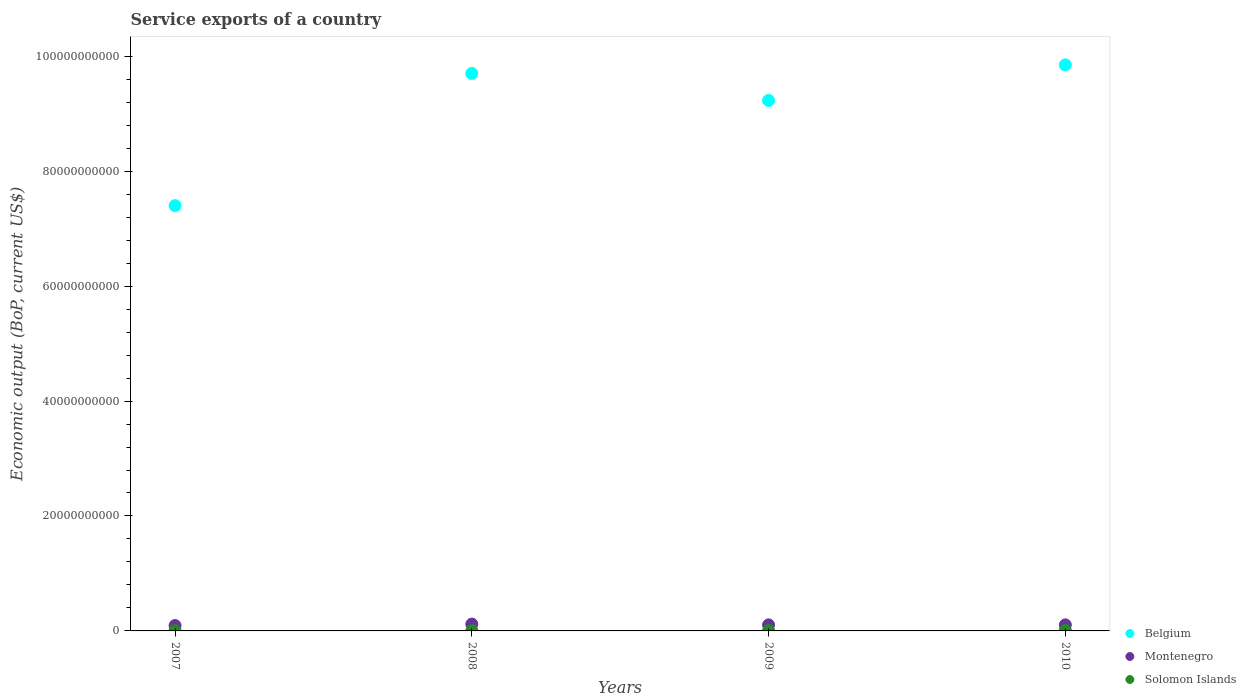What is the service exports in Montenegro in 2007?
Give a very brief answer. 9.33e+08. Across all years, what is the maximum service exports in Belgium?
Give a very brief answer. 9.85e+1. Across all years, what is the minimum service exports in Belgium?
Keep it short and to the point. 7.40e+1. In which year was the service exports in Montenegro minimum?
Offer a very short reply. 2007. What is the total service exports in Belgium in the graph?
Your response must be concise. 3.62e+11. What is the difference between the service exports in Solomon Islands in 2007 and that in 2008?
Your response must be concise. 4.59e+06. What is the difference between the service exports in Solomon Islands in 2008 and the service exports in Belgium in 2007?
Your answer should be compact. -7.40e+1. What is the average service exports in Belgium per year?
Keep it short and to the point. 9.05e+1. In the year 2009, what is the difference between the service exports in Belgium and service exports in Solomon Islands?
Offer a terse response. 9.22e+1. What is the ratio of the service exports in Montenegro in 2007 to that in 2010?
Your answer should be compact. 0.89. What is the difference between the highest and the second highest service exports in Montenegro?
Provide a short and direct response. 1.39e+08. What is the difference between the highest and the lowest service exports in Solomon Islands?
Provide a succinct answer. 4.23e+07. In how many years, is the service exports in Belgium greater than the average service exports in Belgium taken over all years?
Offer a very short reply. 3. Does the service exports in Montenegro monotonically increase over the years?
Provide a succinct answer. No. Does the graph contain grids?
Offer a terse response. No. Where does the legend appear in the graph?
Offer a terse response. Bottom right. What is the title of the graph?
Ensure brevity in your answer.  Service exports of a country. Does "United Arab Emirates" appear as one of the legend labels in the graph?
Your answer should be very brief. No. What is the label or title of the X-axis?
Your answer should be compact. Years. What is the label or title of the Y-axis?
Provide a succinct answer. Economic output (BoP, current US$). What is the Economic output (BoP, current US$) of Belgium in 2007?
Provide a succinct answer. 7.40e+1. What is the Economic output (BoP, current US$) in Montenegro in 2007?
Offer a terse response. 9.33e+08. What is the Economic output (BoP, current US$) in Solomon Islands in 2007?
Offer a very short reply. 5.42e+07. What is the Economic output (BoP, current US$) in Belgium in 2008?
Keep it short and to the point. 9.70e+1. What is the Economic output (BoP, current US$) of Montenegro in 2008?
Keep it short and to the point. 1.19e+09. What is the Economic output (BoP, current US$) in Solomon Islands in 2008?
Ensure brevity in your answer.  4.96e+07. What is the Economic output (BoP, current US$) in Belgium in 2009?
Offer a terse response. 9.23e+1. What is the Economic output (BoP, current US$) of Montenegro in 2009?
Ensure brevity in your answer.  1.05e+09. What is the Economic output (BoP, current US$) of Solomon Islands in 2009?
Offer a very short reply. 5.93e+07. What is the Economic output (BoP, current US$) of Belgium in 2010?
Make the answer very short. 9.85e+1. What is the Economic output (BoP, current US$) of Montenegro in 2010?
Your answer should be compact. 1.05e+09. What is the Economic output (BoP, current US$) of Solomon Islands in 2010?
Your answer should be very brief. 9.19e+07. Across all years, what is the maximum Economic output (BoP, current US$) in Belgium?
Your answer should be very brief. 9.85e+1. Across all years, what is the maximum Economic output (BoP, current US$) of Montenegro?
Offer a very short reply. 1.19e+09. Across all years, what is the maximum Economic output (BoP, current US$) in Solomon Islands?
Offer a very short reply. 9.19e+07. Across all years, what is the minimum Economic output (BoP, current US$) in Belgium?
Offer a very short reply. 7.40e+1. Across all years, what is the minimum Economic output (BoP, current US$) of Montenegro?
Provide a short and direct response. 9.33e+08. Across all years, what is the minimum Economic output (BoP, current US$) of Solomon Islands?
Offer a terse response. 4.96e+07. What is the total Economic output (BoP, current US$) of Belgium in the graph?
Keep it short and to the point. 3.62e+11. What is the total Economic output (BoP, current US$) of Montenegro in the graph?
Offer a terse response. 4.23e+09. What is the total Economic output (BoP, current US$) of Solomon Islands in the graph?
Offer a terse response. 2.55e+08. What is the difference between the Economic output (BoP, current US$) in Belgium in 2007 and that in 2008?
Provide a short and direct response. -2.30e+1. What is the difference between the Economic output (BoP, current US$) of Montenegro in 2007 and that in 2008?
Provide a succinct answer. -2.60e+08. What is the difference between the Economic output (BoP, current US$) of Solomon Islands in 2007 and that in 2008?
Your answer should be compact. 4.59e+06. What is the difference between the Economic output (BoP, current US$) of Belgium in 2007 and that in 2009?
Your answer should be very brief. -1.83e+1. What is the difference between the Economic output (BoP, current US$) in Montenegro in 2007 and that in 2009?
Your response must be concise. -1.20e+08. What is the difference between the Economic output (BoP, current US$) in Solomon Islands in 2007 and that in 2009?
Provide a succinct answer. -5.10e+06. What is the difference between the Economic output (BoP, current US$) in Belgium in 2007 and that in 2010?
Your response must be concise. -2.45e+1. What is the difference between the Economic output (BoP, current US$) of Montenegro in 2007 and that in 2010?
Your answer should be compact. -1.20e+08. What is the difference between the Economic output (BoP, current US$) in Solomon Islands in 2007 and that in 2010?
Keep it short and to the point. -3.77e+07. What is the difference between the Economic output (BoP, current US$) of Belgium in 2008 and that in 2009?
Keep it short and to the point. 4.70e+09. What is the difference between the Economic output (BoP, current US$) of Montenegro in 2008 and that in 2009?
Make the answer very short. 1.40e+08. What is the difference between the Economic output (BoP, current US$) in Solomon Islands in 2008 and that in 2009?
Give a very brief answer. -9.69e+06. What is the difference between the Economic output (BoP, current US$) in Belgium in 2008 and that in 2010?
Give a very brief answer. -1.49e+09. What is the difference between the Economic output (BoP, current US$) in Montenegro in 2008 and that in 2010?
Your answer should be compact. 1.39e+08. What is the difference between the Economic output (BoP, current US$) in Solomon Islands in 2008 and that in 2010?
Your answer should be compact. -4.23e+07. What is the difference between the Economic output (BoP, current US$) in Belgium in 2009 and that in 2010?
Your answer should be very brief. -6.19e+09. What is the difference between the Economic output (BoP, current US$) of Montenegro in 2009 and that in 2010?
Offer a very short reply. -4.45e+05. What is the difference between the Economic output (BoP, current US$) of Solomon Islands in 2009 and that in 2010?
Keep it short and to the point. -3.26e+07. What is the difference between the Economic output (BoP, current US$) in Belgium in 2007 and the Economic output (BoP, current US$) in Montenegro in 2008?
Provide a succinct answer. 7.28e+1. What is the difference between the Economic output (BoP, current US$) of Belgium in 2007 and the Economic output (BoP, current US$) of Solomon Islands in 2008?
Provide a short and direct response. 7.40e+1. What is the difference between the Economic output (BoP, current US$) in Montenegro in 2007 and the Economic output (BoP, current US$) in Solomon Islands in 2008?
Your response must be concise. 8.84e+08. What is the difference between the Economic output (BoP, current US$) of Belgium in 2007 and the Economic output (BoP, current US$) of Montenegro in 2009?
Your answer should be compact. 7.29e+1. What is the difference between the Economic output (BoP, current US$) of Belgium in 2007 and the Economic output (BoP, current US$) of Solomon Islands in 2009?
Provide a short and direct response. 7.39e+1. What is the difference between the Economic output (BoP, current US$) of Montenegro in 2007 and the Economic output (BoP, current US$) of Solomon Islands in 2009?
Your answer should be compact. 8.74e+08. What is the difference between the Economic output (BoP, current US$) in Belgium in 2007 and the Economic output (BoP, current US$) in Montenegro in 2010?
Your answer should be very brief. 7.29e+1. What is the difference between the Economic output (BoP, current US$) of Belgium in 2007 and the Economic output (BoP, current US$) of Solomon Islands in 2010?
Give a very brief answer. 7.39e+1. What is the difference between the Economic output (BoP, current US$) in Montenegro in 2007 and the Economic output (BoP, current US$) in Solomon Islands in 2010?
Make the answer very short. 8.41e+08. What is the difference between the Economic output (BoP, current US$) in Belgium in 2008 and the Economic output (BoP, current US$) in Montenegro in 2009?
Ensure brevity in your answer.  9.60e+1. What is the difference between the Economic output (BoP, current US$) of Belgium in 2008 and the Economic output (BoP, current US$) of Solomon Islands in 2009?
Provide a succinct answer. 9.69e+1. What is the difference between the Economic output (BoP, current US$) in Montenegro in 2008 and the Economic output (BoP, current US$) in Solomon Islands in 2009?
Make the answer very short. 1.13e+09. What is the difference between the Economic output (BoP, current US$) of Belgium in 2008 and the Economic output (BoP, current US$) of Montenegro in 2010?
Offer a very short reply. 9.60e+1. What is the difference between the Economic output (BoP, current US$) in Belgium in 2008 and the Economic output (BoP, current US$) in Solomon Islands in 2010?
Your answer should be compact. 9.69e+1. What is the difference between the Economic output (BoP, current US$) in Montenegro in 2008 and the Economic output (BoP, current US$) in Solomon Islands in 2010?
Ensure brevity in your answer.  1.10e+09. What is the difference between the Economic output (BoP, current US$) in Belgium in 2009 and the Economic output (BoP, current US$) in Montenegro in 2010?
Your answer should be very brief. 9.13e+1. What is the difference between the Economic output (BoP, current US$) of Belgium in 2009 and the Economic output (BoP, current US$) of Solomon Islands in 2010?
Give a very brief answer. 9.22e+1. What is the difference between the Economic output (BoP, current US$) in Montenegro in 2009 and the Economic output (BoP, current US$) in Solomon Islands in 2010?
Keep it short and to the point. 9.61e+08. What is the average Economic output (BoP, current US$) of Belgium per year?
Give a very brief answer. 9.05e+1. What is the average Economic output (BoP, current US$) in Montenegro per year?
Ensure brevity in your answer.  1.06e+09. What is the average Economic output (BoP, current US$) of Solomon Islands per year?
Keep it short and to the point. 6.38e+07. In the year 2007, what is the difference between the Economic output (BoP, current US$) in Belgium and Economic output (BoP, current US$) in Montenegro?
Give a very brief answer. 7.31e+1. In the year 2007, what is the difference between the Economic output (BoP, current US$) of Belgium and Economic output (BoP, current US$) of Solomon Islands?
Your answer should be compact. 7.39e+1. In the year 2007, what is the difference between the Economic output (BoP, current US$) of Montenegro and Economic output (BoP, current US$) of Solomon Islands?
Offer a very short reply. 8.79e+08. In the year 2008, what is the difference between the Economic output (BoP, current US$) of Belgium and Economic output (BoP, current US$) of Montenegro?
Your answer should be very brief. 9.58e+1. In the year 2008, what is the difference between the Economic output (BoP, current US$) of Belgium and Economic output (BoP, current US$) of Solomon Islands?
Ensure brevity in your answer.  9.70e+1. In the year 2008, what is the difference between the Economic output (BoP, current US$) of Montenegro and Economic output (BoP, current US$) of Solomon Islands?
Provide a succinct answer. 1.14e+09. In the year 2009, what is the difference between the Economic output (BoP, current US$) of Belgium and Economic output (BoP, current US$) of Montenegro?
Offer a terse response. 9.13e+1. In the year 2009, what is the difference between the Economic output (BoP, current US$) of Belgium and Economic output (BoP, current US$) of Solomon Islands?
Your answer should be very brief. 9.22e+1. In the year 2009, what is the difference between the Economic output (BoP, current US$) in Montenegro and Economic output (BoP, current US$) in Solomon Islands?
Offer a terse response. 9.94e+08. In the year 2010, what is the difference between the Economic output (BoP, current US$) of Belgium and Economic output (BoP, current US$) of Montenegro?
Make the answer very short. 9.74e+1. In the year 2010, what is the difference between the Economic output (BoP, current US$) in Belgium and Economic output (BoP, current US$) in Solomon Islands?
Provide a short and direct response. 9.84e+1. In the year 2010, what is the difference between the Economic output (BoP, current US$) in Montenegro and Economic output (BoP, current US$) in Solomon Islands?
Your answer should be very brief. 9.61e+08. What is the ratio of the Economic output (BoP, current US$) of Belgium in 2007 to that in 2008?
Make the answer very short. 0.76. What is the ratio of the Economic output (BoP, current US$) in Montenegro in 2007 to that in 2008?
Your answer should be compact. 0.78. What is the ratio of the Economic output (BoP, current US$) of Solomon Islands in 2007 to that in 2008?
Keep it short and to the point. 1.09. What is the ratio of the Economic output (BoP, current US$) in Belgium in 2007 to that in 2009?
Ensure brevity in your answer.  0.8. What is the ratio of the Economic output (BoP, current US$) in Montenegro in 2007 to that in 2009?
Make the answer very short. 0.89. What is the ratio of the Economic output (BoP, current US$) in Solomon Islands in 2007 to that in 2009?
Offer a very short reply. 0.91. What is the ratio of the Economic output (BoP, current US$) of Belgium in 2007 to that in 2010?
Offer a very short reply. 0.75. What is the ratio of the Economic output (BoP, current US$) of Montenegro in 2007 to that in 2010?
Provide a short and direct response. 0.89. What is the ratio of the Economic output (BoP, current US$) of Solomon Islands in 2007 to that in 2010?
Provide a short and direct response. 0.59. What is the ratio of the Economic output (BoP, current US$) of Belgium in 2008 to that in 2009?
Your answer should be compact. 1.05. What is the ratio of the Economic output (BoP, current US$) of Montenegro in 2008 to that in 2009?
Your answer should be compact. 1.13. What is the ratio of the Economic output (BoP, current US$) of Solomon Islands in 2008 to that in 2009?
Provide a succinct answer. 0.84. What is the ratio of the Economic output (BoP, current US$) in Belgium in 2008 to that in 2010?
Keep it short and to the point. 0.98. What is the ratio of the Economic output (BoP, current US$) of Montenegro in 2008 to that in 2010?
Provide a succinct answer. 1.13. What is the ratio of the Economic output (BoP, current US$) of Solomon Islands in 2008 to that in 2010?
Make the answer very short. 0.54. What is the ratio of the Economic output (BoP, current US$) of Belgium in 2009 to that in 2010?
Ensure brevity in your answer.  0.94. What is the ratio of the Economic output (BoP, current US$) in Montenegro in 2009 to that in 2010?
Offer a terse response. 1. What is the ratio of the Economic output (BoP, current US$) in Solomon Islands in 2009 to that in 2010?
Provide a succinct answer. 0.65. What is the difference between the highest and the second highest Economic output (BoP, current US$) in Belgium?
Offer a very short reply. 1.49e+09. What is the difference between the highest and the second highest Economic output (BoP, current US$) in Montenegro?
Make the answer very short. 1.39e+08. What is the difference between the highest and the second highest Economic output (BoP, current US$) in Solomon Islands?
Your response must be concise. 3.26e+07. What is the difference between the highest and the lowest Economic output (BoP, current US$) in Belgium?
Ensure brevity in your answer.  2.45e+1. What is the difference between the highest and the lowest Economic output (BoP, current US$) of Montenegro?
Give a very brief answer. 2.60e+08. What is the difference between the highest and the lowest Economic output (BoP, current US$) in Solomon Islands?
Offer a terse response. 4.23e+07. 